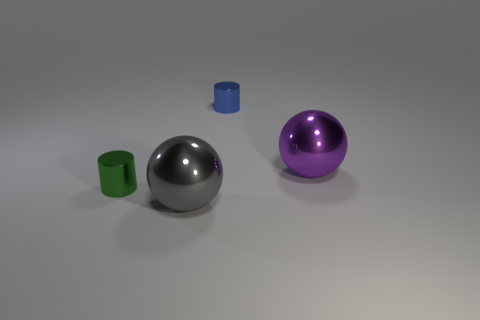How many small blue metal objects are on the right side of the purple thing?
Give a very brief answer. 0. Is there a blue object?
Your answer should be very brief. Yes. There is a thing that is to the right of the small metallic cylinder that is on the right side of the small thing that is in front of the purple thing; what is its size?
Ensure brevity in your answer.  Large. What number of other things are the same size as the purple metal object?
Keep it short and to the point. 1. How big is the shiny sphere that is behind the gray object?
Provide a short and direct response. Large. Is the material of the tiny object that is in front of the purple sphere the same as the tiny blue cylinder?
Keep it short and to the point. Yes. How many objects are on the right side of the blue shiny cylinder and behind the purple metallic object?
Your response must be concise. 0. What is the size of the metal ball that is on the left side of the tiny object that is behind the purple metal object?
Your response must be concise. Large. Is there any other thing that is made of the same material as the green cylinder?
Give a very brief answer. Yes. Is the number of green shiny cylinders greater than the number of large matte cylinders?
Your answer should be very brief. Yes. 